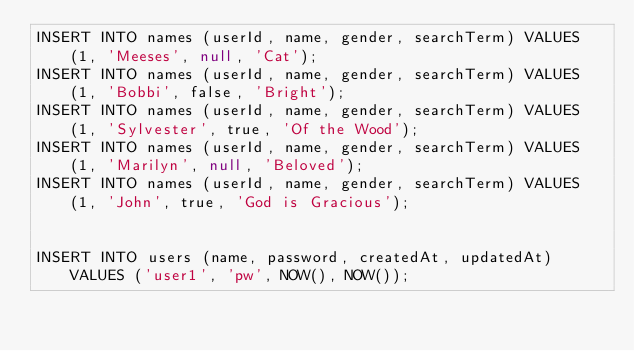<code> <loc_0><loc_0><loc_500><loc_500><_SQL_>INSERT INTO names (userId, name, gender, searchTerm) VALUES (1, 'Meeses', null, 'Cat');
INSERT INTO names (userId, name, gender, searchTerm) VALUES (1, 'Bobbi', false, 'Bright');
INSERT INTO names (userId, name, gender, searchTerm) VALUES (1, 'Sylvester', true, 'Of the Wood');
INSERT INTO names (userId, name, gender, searchTerm) VALUES (1, 'Marilyn', null, 'Beloved');
INSERT INTO names (userId, name, gender, searchTerm) VALUES (1, 'John', true, 'God is Gracious');


INSERT INTO users (name, password, createdAt, updatedAt) VALUES ('user1', 'pw', NOW(), NOW());
</code> 